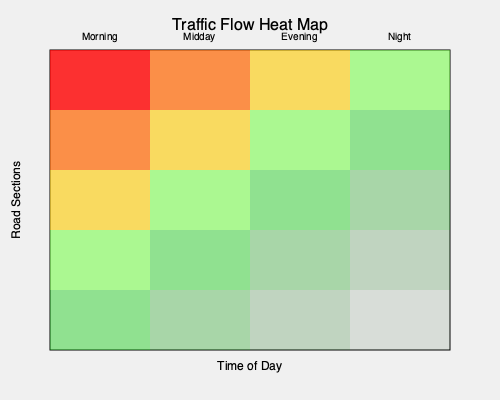Based on the traffic flow heat map, during which time of day would you expect to encounter the heaviest traffic congestion, and how might this information influence your route planning as a taxi driver? To answer this question, we need to analyze the heat map step-by-step:

1. Interpret the color scheme:
   - Red indicates high traffic congestion
   - Orange indicates moderate to high congestion
   - Yellow indicates moderate congestion
   - Green indicates low congestion

2. Analyze the time periods:
   - The x-axis represents different times of the day (Morning, Midday, Evening, Night)
   - The y-axis represents different road sections

3. Identify the heaviest traffic:
   - The darkest red area is in the top-left corner of the heat map
   - This corresponds to the morning time period and the topmost road section

4. Consider the implications for route planning:
   - As a taxi driver, you would want to avoid the most congested areas during peak times
   - Morning rush hour appears to be the most challenging time for traffic

5. Strategize based on the information:
   - Plan alternative routes that avoid the most congested road sections during morning hours
   - Consider suggesting earlier departure times to passengers during morning peak hours
   - Utilize less congested routes shown in yellow or green during other times of the day

6. Optimize earnings:
   - During high congestion times, focus on shorter trips or use alternative pricing models (if applicable)
   - During low congestion times (green areas), longer trips might be more profitable due to faster travel times

By understanding this traffic pattern, you can make informed decisions about route selection, manage passenger expectations, and potentially increase your efficiency and earnings as a taxi driver.
Answer: Morning; avoid congested routes, suggest earlier departures, use alternative roads. 